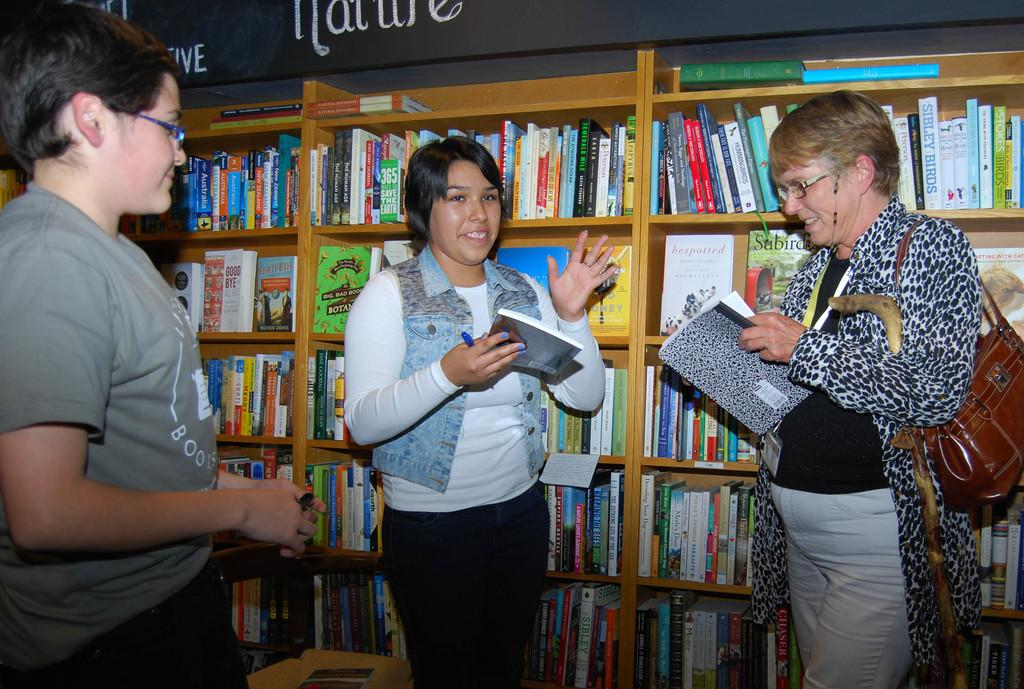<image>
Provide a brief description of the given image. Three people are having a discussion in front of a wall of book shelves, with books that include 365 Way to Save the Earth, Good Bye, and Bespotted. 